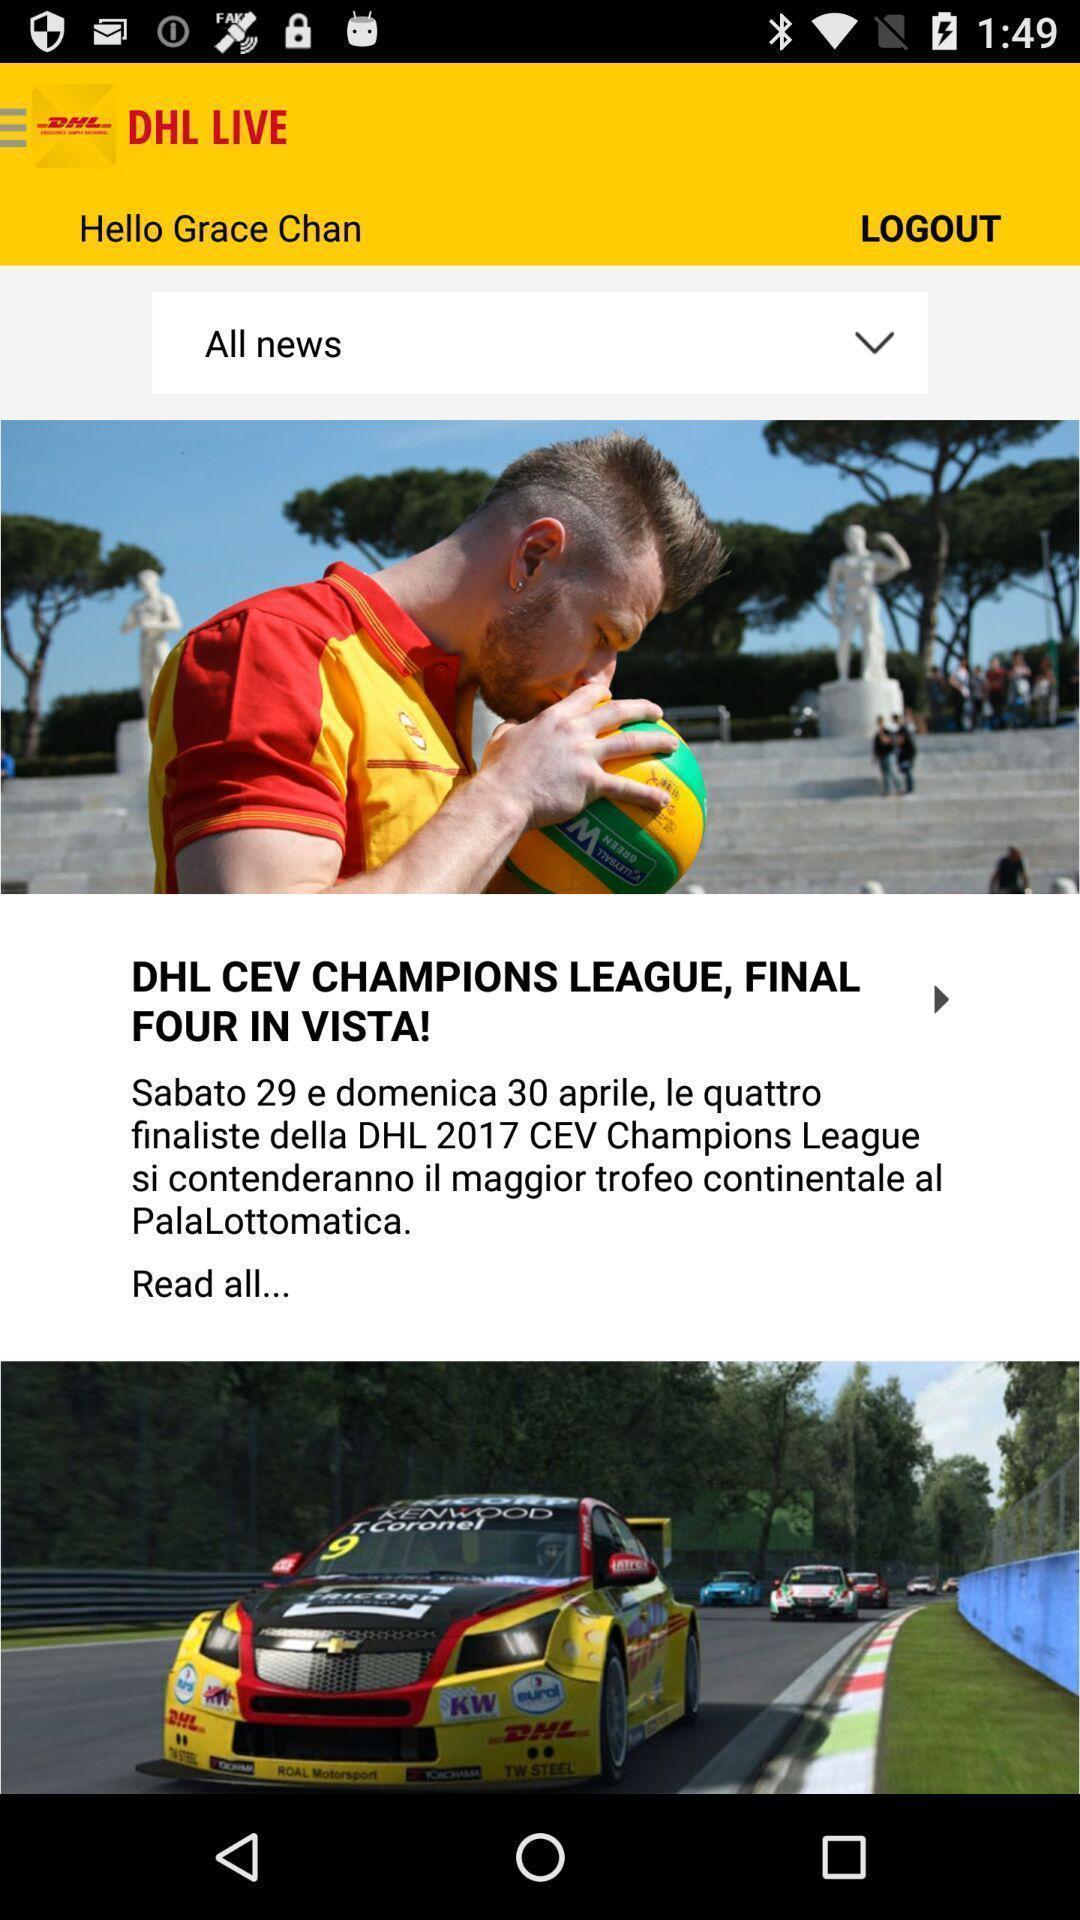Tell me about the visual elements in this screen capture. Screen displaying news page. 